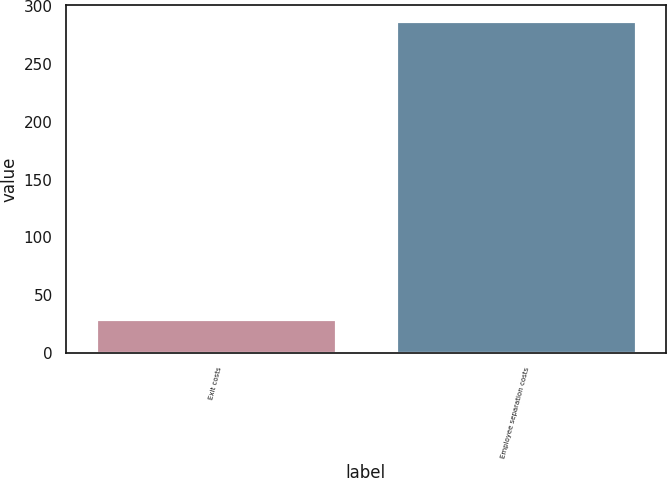<chart> <loc_0><loc_0><loc_500><loc_500><bar_chart><fcel>Exit costs<fcel>Employee separation costs<nl><fcel>29<fcel>287<nl></chart> 